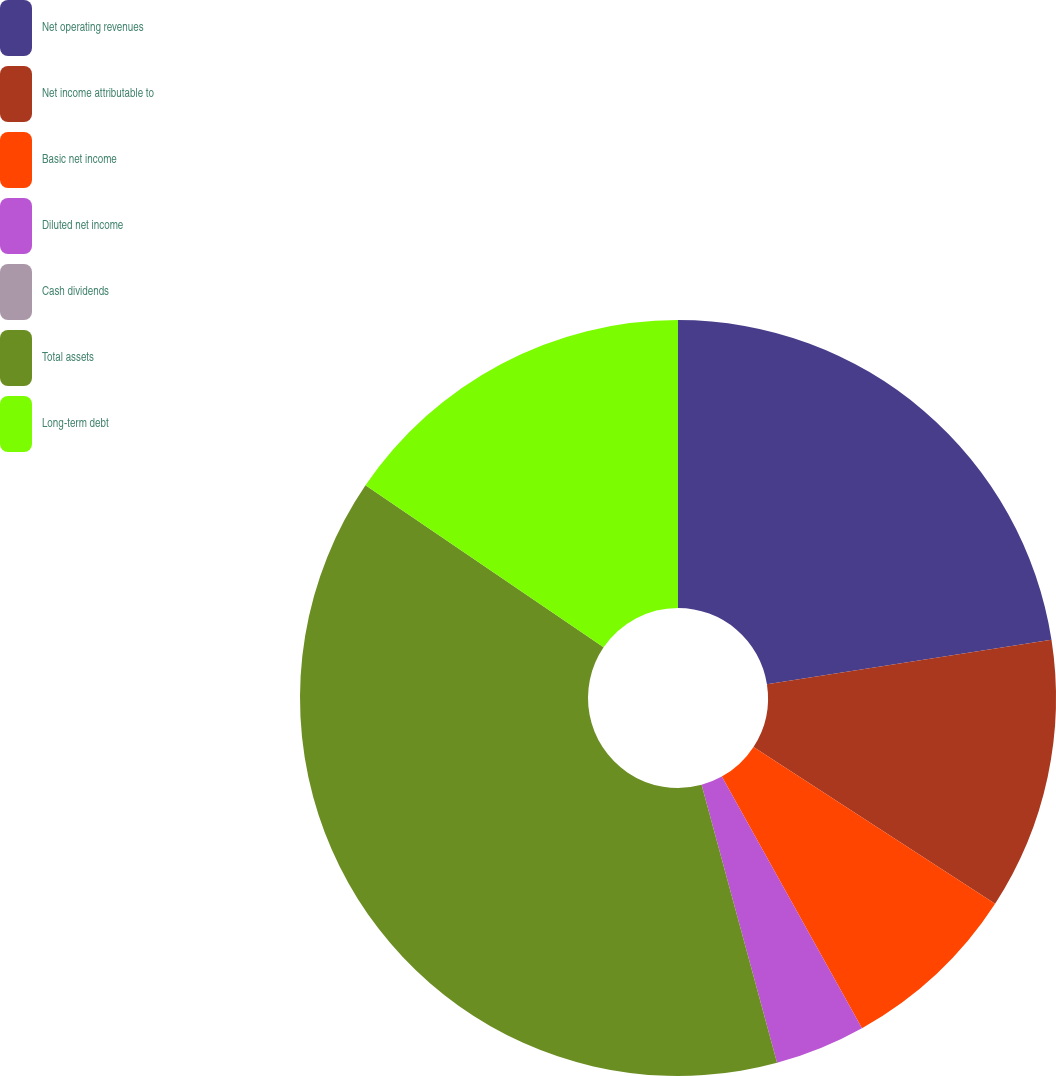Convert chart. <chart><loc_0><loc_0><loc_500><loc_500><pie_chart><fcel>Net operating revenues<fcel>Net income attributable to<fcel>Basic net income<fcel>Diluted net income<fcel>Cash dividends<fcel>Total assets<fcel>Long-term debt<nl><fcel>22.54%<fcel>11.62%<fcel>7.75%<fcel>3.87%<fcel>0.0%<fcel>38.73%<fcel>15.49%<nl></chart> 